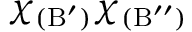Convert formula to latex. <formula><loc_0><loc_0><loc_500><loc_500>\chi _ { ( B ^ { \prime } ) } \chi _ { ( B ^ { \prime \prime } ) }</formula> 